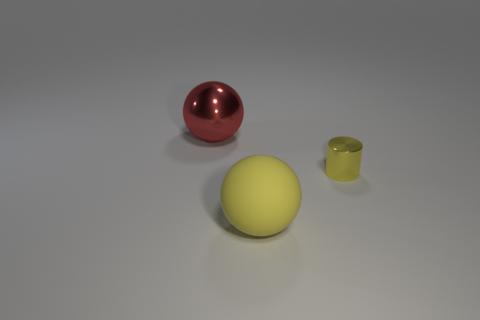There is a sphere that is right of the large thing that is behind the tiny yellow cylinder; how many yellow shiny cylinders are to the left of it?
Your response must be concise. 0. What is the shape of the thing that is both in front of the large red object and to the left of the yellow shiny cylinder?
Ensure brevity in your answer.  Sphere. Are there fewer large shiny spheres that are behind the big red ball than tiny metal objects?
Your response must be concise. Yes. What number of large things are red rubber cylinders or yellow metallic cylinders?
Ensure brevity in your answer.  0. How big is the red metal thing?
Offer a very short reply. Large. Is there any other thing that has the same material as the large yellow ball?
Provide a short and direct response. No. There is a tiny cylinder; what number of yellow rubber spheres are in front of it?
Keep it short and to the point. 1. What size is the yellow rubber thing that is the same shape as the red metal object?
Give a very brief answer. Large. What size is the object that is both behind the rubber sphere and on the left side of the tiny yellow cylinder?
Your response must be concise. Large. Do the small shiny cylinder and the large sphere that is in front of the tiny yellow cylinder have the same color?
Give a very brief answer. Yes. 